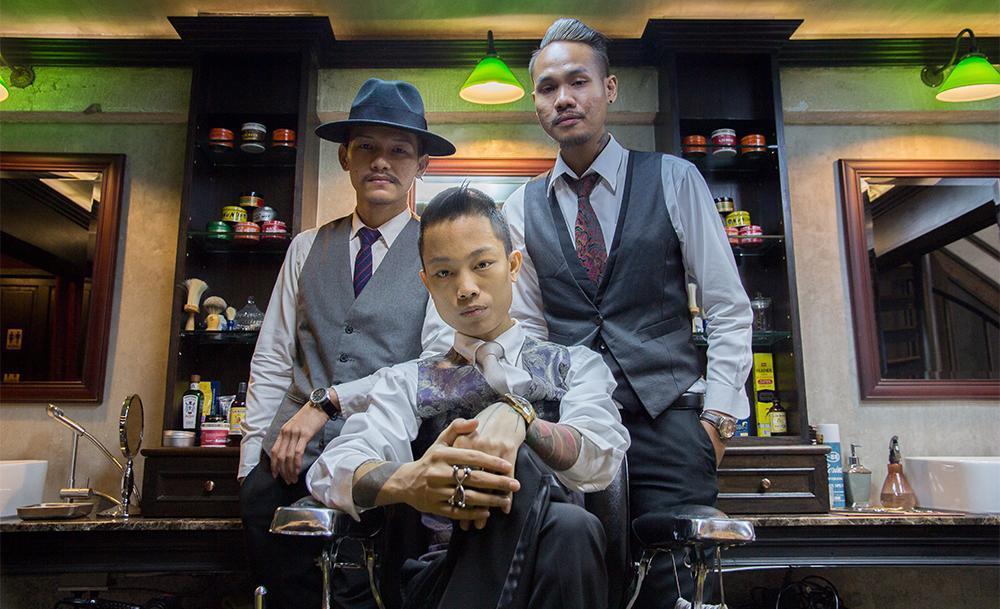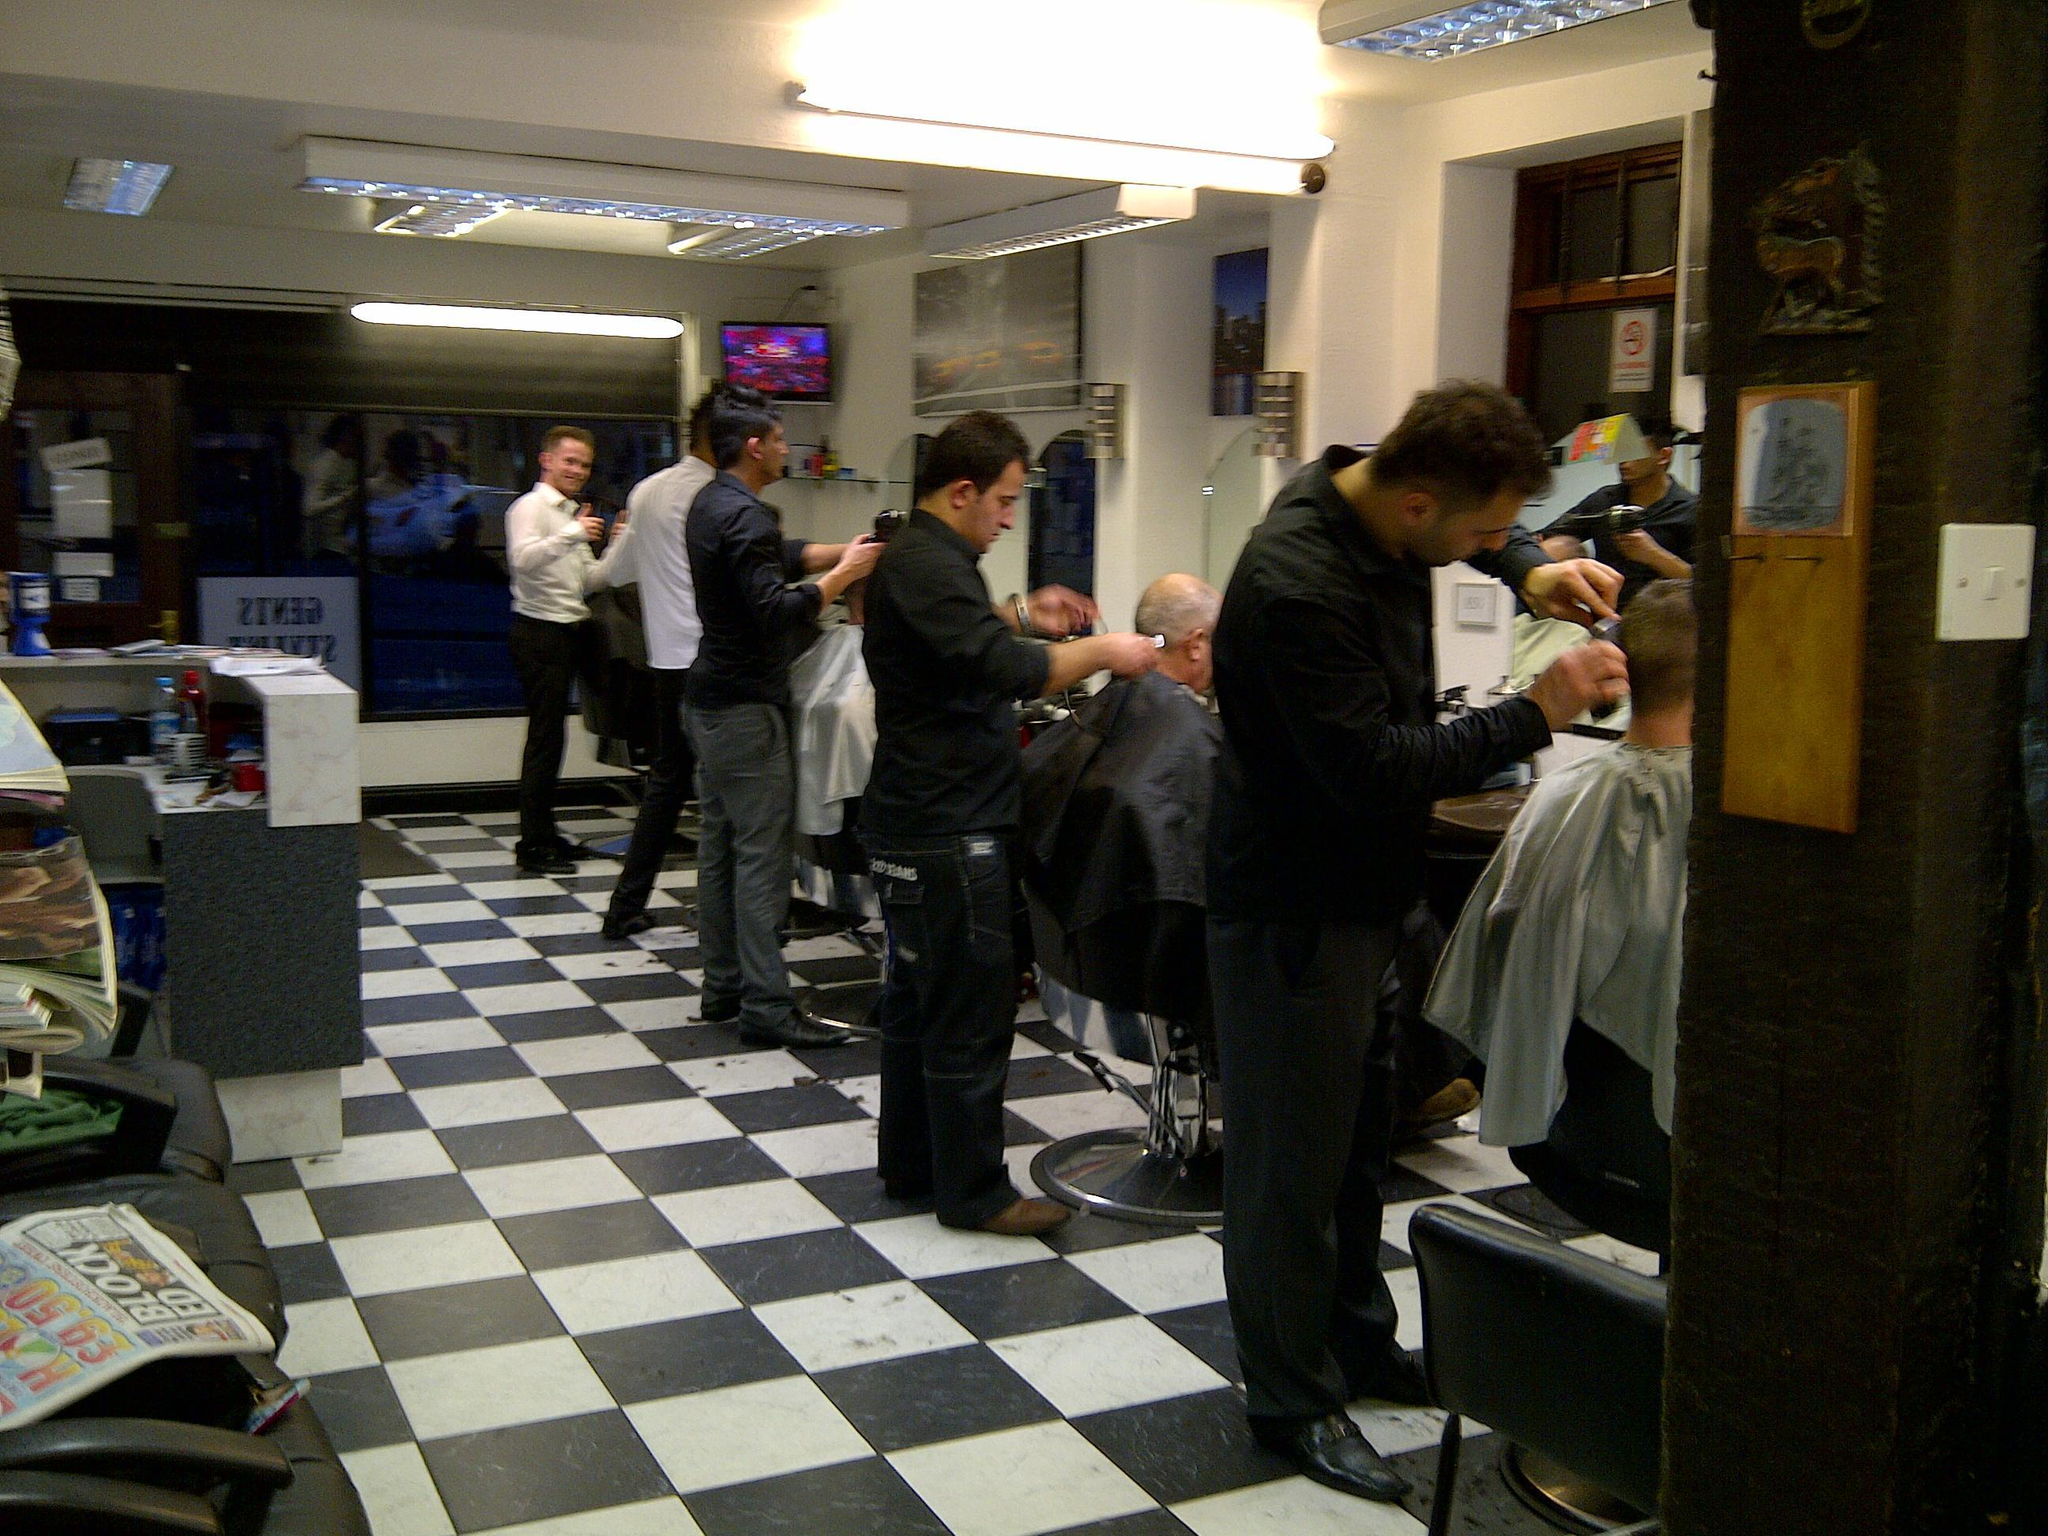The first image is the image on the left, the second image is the image on the right. Analyze the images presented: Is the assertion "One man is sitting between two other men in the image on the right." valid? Answer yes or no. No. The first image is the image on the left, the second image is the image on the right. Considering the images on both sides, is "A female wearing black stands in the foreground of the image on the left." valid? Answer yes or no. No. 